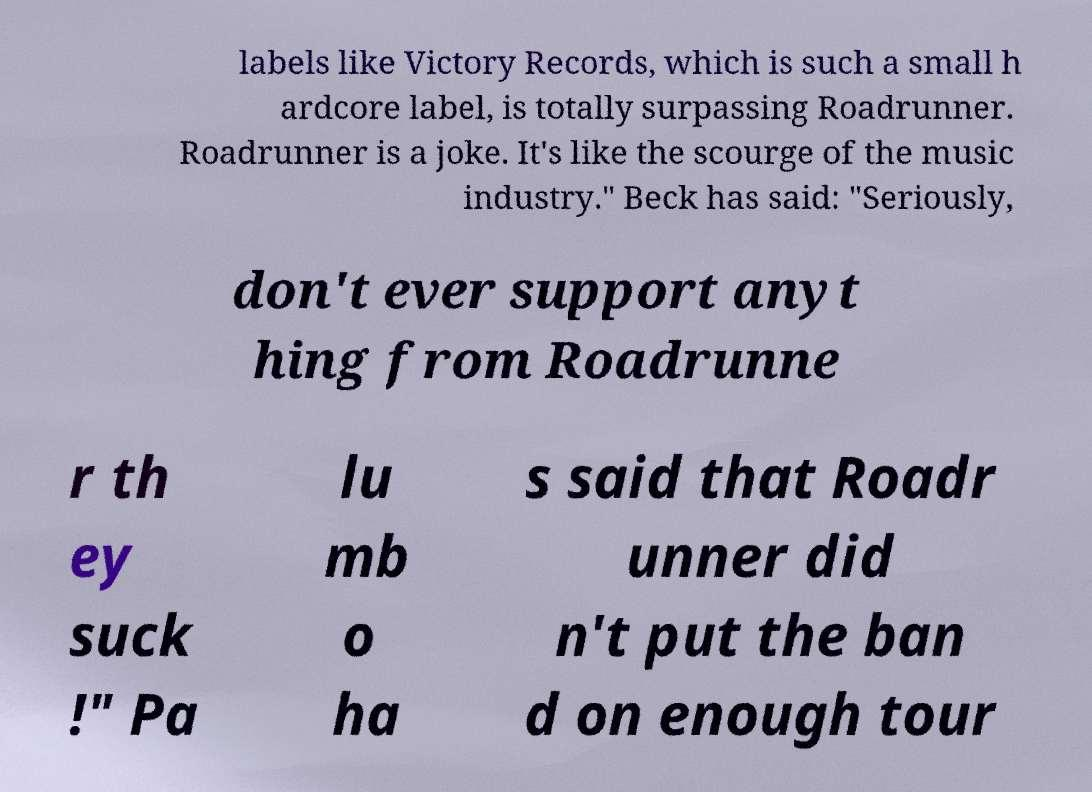Can you read and provide the text displayed in the image?This photo seems to have some interesting text. Can you extract and type it out for me? labels like Victory Records, which is such a small h ardcore label, is totally surpassing Roadrunner. Roadrunner is a joke. It's like the scourge of the music industry." Beck has said: "Seriously, don't ever support anyt hing from Roadrunne r th ey suck !" Pa lu mb o ha s said that Roadr unner did n't put the ban d on enough tour 